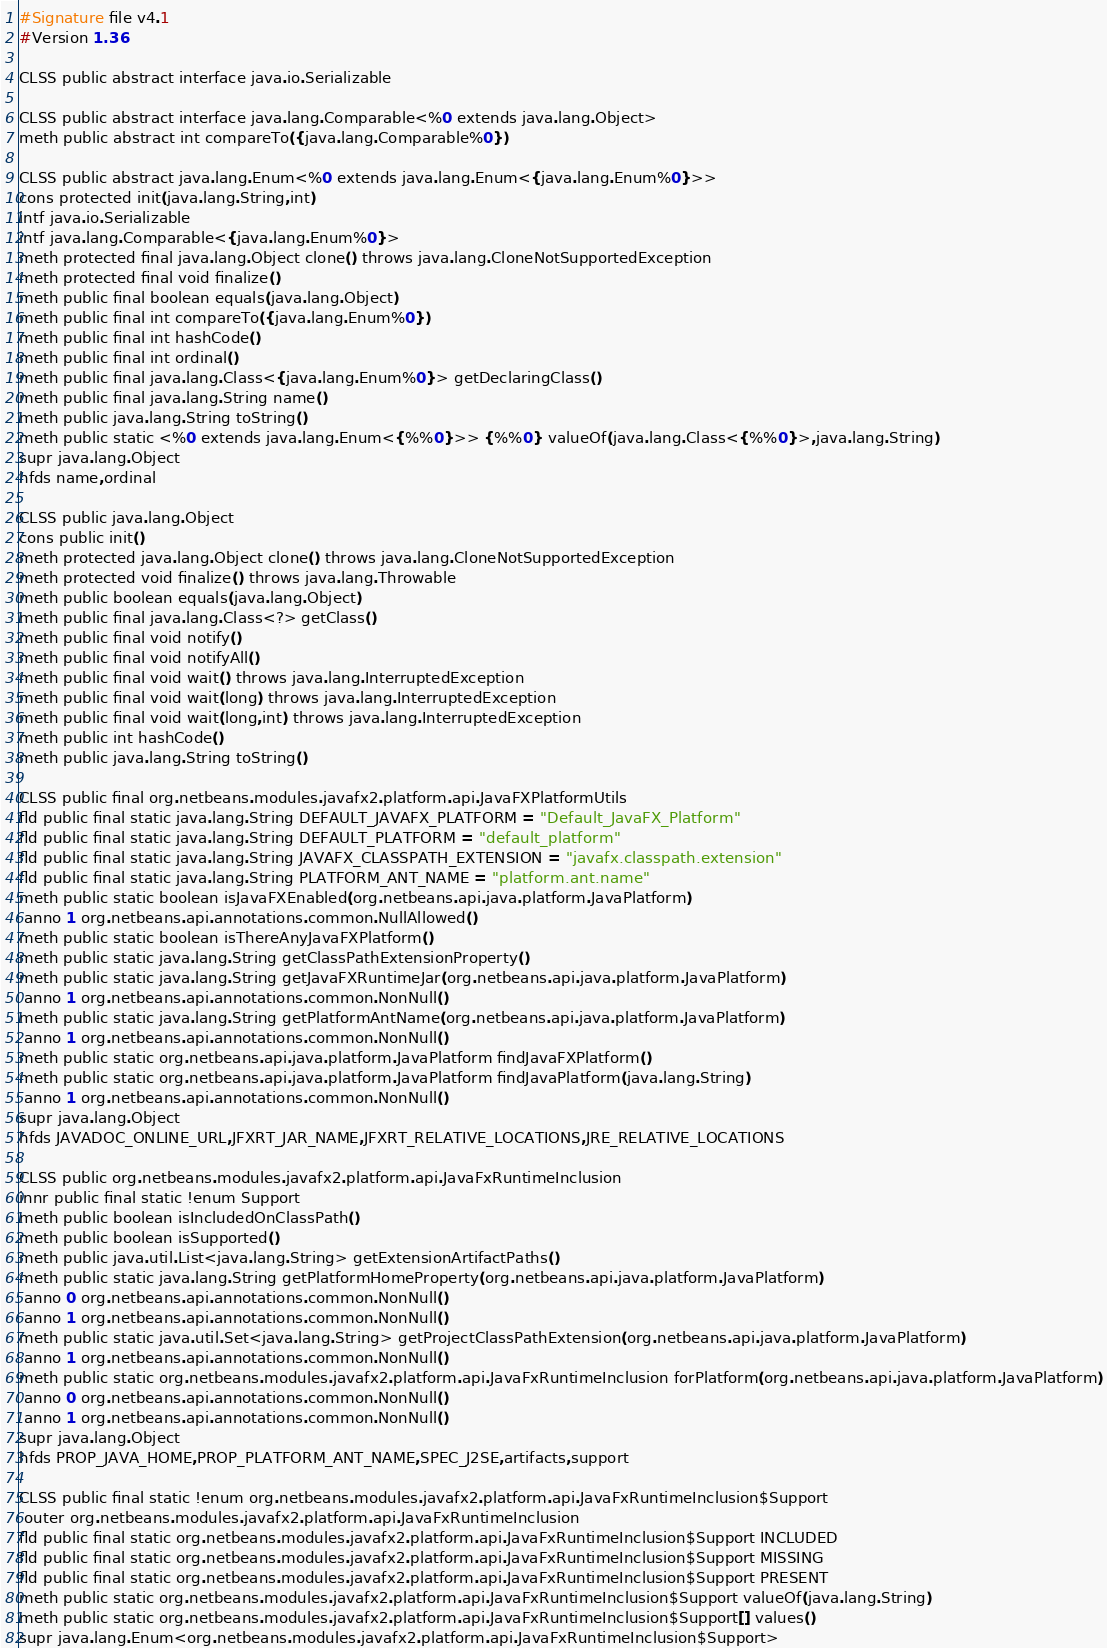Convert code to text. <code><loc_0><loc_0><loc_500><loc_500><_SML_>#Signature file v4.1
#Version 1.36

CLSS public abstract interface java.io.Serializable

CLSS public abstract interface java.lang.Comparable<%0 extends java.lang.Object>
meth public abstract int compareTo({java.lang.Comparable%0})

CLSS public abstract java.lang.Enum<%0 extends java.lang.Enum<{java.lang.Enum%0}>>
cons protected init(java.lang.String,int)
intf java.io.Serializable
intf java.lang.Comparable<{java.lang.Enum%0}>
meth protected final java.lang.Object clone() throws java.lang.CloneNotSupportedException
meth protected final void finalize()
meth public final boolean equals(java.lang.Object)
meth public final int compareTo({java.lang.Enum%0})
meth public final int hashCode()
meth public final int ordinal()
meth public final java.lang.Class<{java.lang.Enum%0}> getDeclaringClass()
meth public final java.lang.String name()
meth public java.lang.String toString()
meth public static <%0 extends java.lang.Enum<{%%0}>> {%%0} valueOf(java.lang.Class<{%%0}>,java.lang.String)
supr java.lang.Object
hfds name,ordinal

CLSS public java.lang.Object
cons public init()
meth protected java.lang.Object clone() throws java.lang.CloneNotSupportedException
meth protected void finalize() throws java.lang.Throwable
meth public boolean equals(java.lang.Object)
meth public final java.lang.Class<?> getClass()
meth public final void notify()
meth public final void notifyAll()
meth public final void wait() throws java.lang.InterruptedException
meth public final void wait(long) throws java.lang.InterruptedException
meth public final void wait(long,int) throws java.lang.InterruptedException
meth public int hashCode()
meth public java.lang.String toString()

CLSS public final org.netbeans.modules.javafx2.platform.api.JavaFXPlatformUtils
fld public final static java.lang.String DEFAULT_JAVAFX_PLATFORM = "Default_JavaFX_Platform"
fld public final static java.lang.String DEFAULT_PLATFORM = "default_platform"
fld public final static java.lang.String JAVAFX_CLASSPATH_EXTENSION = "javafx.classpath.extension"
fld public final static java.lang.String PLATFORM_ANT_NAME = "platform.ant.name"
meth public static boolean isJavaFXEnabled(org.netbeans.api.java.platform.JavaPlatform)
 anno 1 org.netbeans.api.annotations.common.NullAllowed()
meth public static boolean isThereAnyJavaFXPlatform()
meth public static java.lang.String getClassPathExtensionProperty()
meth public static java.lang.String getJavaFXRuntimeJar(org.netbeans.api.java.platform.JavaPlatform)
 anno 1 org.netbeans.api.annotations.common.NonNull()
meth public static java.lang.String getPlatformAntName(org.netbeans.api.java.platform.JavaPlatform)
 anno 1 org.netbeans.api.annotations.common.NonNull()
meth public static org.netbeans.api.java.platform.JavaPlatform findJavaFXPlatform()
meth public static org.netbeans.api.java.platform.JavaPlatform findJavaPlatform(java.lang.String)
 anno 1 org.netbeans.api.annotations.common.NonNull()
supr java.lang.Object
hfds JAVADOC_ONLINE_URL,JFXRT_JAR_NAME,JFXRT_RELATIVE_LOCATIONS,JRE_RELATIVE_LOCATIONS

CLSS public org.netbeans.modules.javafx2.platform.api.JavaFxRuntimeInclusion
innr public final static !enum Support
meth public boolean isIncludedOnClassPath()
meth public boolean isSupported()
meth public java.util.List<java.lang.String> getExtensionArtifactPaths()
meth public static java.lang.String getPlatformHomeProperty(org.netbeans.api.java.platform.JavaPlatform)
 anno 0 org.netbeans.api.annotations.common.NonNull()
 anno 1 org.netbeans.api.annotations.common.NonNull()
meth public static java.util.Set<java.lang.String> getProjectClassPathExtension(org.netbeans.api.java.platform.JavaPlatform)
 anno 1 org.netbeans.api.annotations.common.NonNull()
meth public static org.netbeans.modules.javafx2.platform.api.JavaFxRuntimeInclusion forPlatform(org.netbeans.api.java.platform.JavaPlatform)
 anno 0 org.netbeans.api.annotations.common.NonNull()
 anno 1 org.netbeans.api.annotations.common.NonNull()
supr java.lang.Object
hfds PROP_JAVA_HOME,PROP_PLATFORM_ANT_NAME,SPEC_J2SE,artifacts,support

CLSS public final static !enum org.netbeans.modules.javafx2.platform.api.JavaFxRuntimeInclusion$Support
 outer org.netbeans.modules.javafx2.platform.api.JavaFxRuntimeInclusion
fld public final static org.netbeans.modules.javafx2.platform.api.JavaFxRuntimeInclusion$Support INCLUDED
fld public final static org.netbeans.modules.javafx2.platform.api.JavaFxRuntimeInclusion$Support MISSING
fld public final static org.netbeans.modules.javafx2.platform.api.JavaFxRuntimeInclusion$Support PRESENT
meth public static org.netbeans.modules.javafx2.platform.api.JavaFxRuntimeInclusion$Support valueOf(java.lang.String)
meth public static org.netbeans.modules.javafx2.platform.api.JavaFxRuntimeInclusion$Support[] values()
supr java.lang.Enum<org.netbeans.modules.javafx2.platform.api.JavaFxRuntimeInclusion$Support>

</code> 